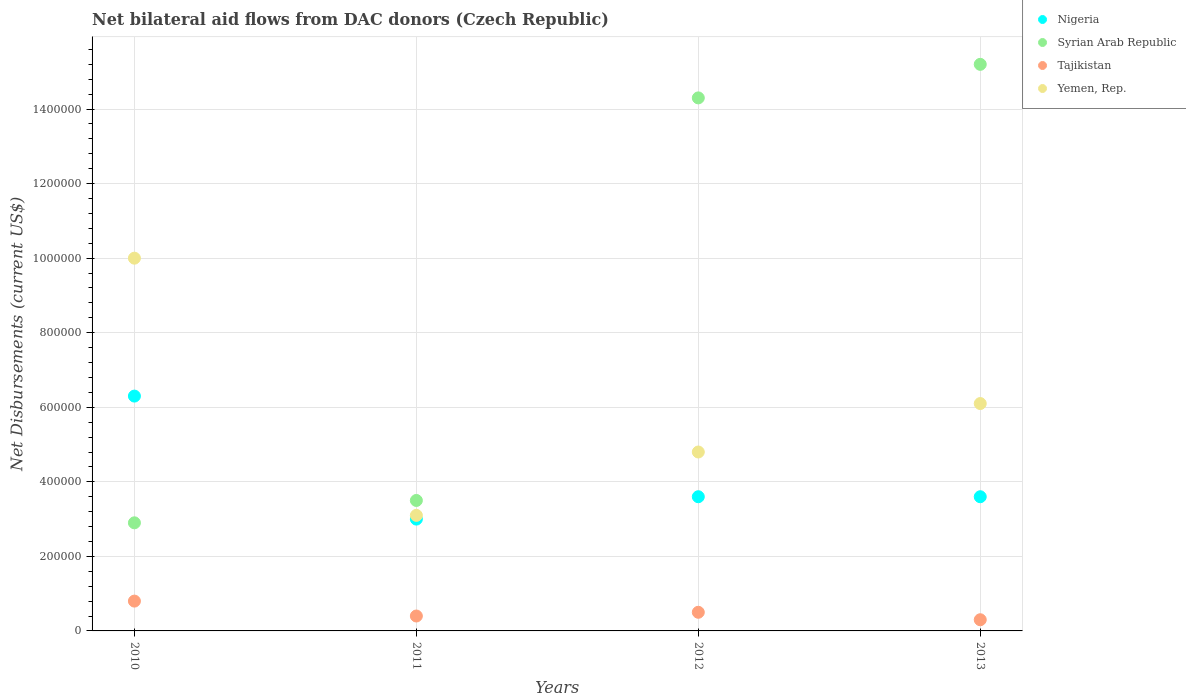How many different coloured dotlines are there?
Provide a short and direct response. 4. What is the net bilateral aid flows in Tajikistan in 2010?
Give a very brief answer. 8.00e+04. Across all years, what is the maximum net bilateral aid flows in Nigeria?
Offer a very short reply. 6.30e+05. Across all years, what is the minimum net bilateral aid flows in Syrian Arab Republic?
Offer a terse response. 2.90e+05. What is the total net bilateral aid flows in Syrian Arab Republic in the graph?
Provide a short and direct response. 3.59e+06. What is the difference between the net bilateral aid flows in Syrian Arab Republic in 2010 and that in 2011?
Make the answer very short. -6.00e+04. What is the difference between the net bilateral aid flows in Nigeria in 2013 and the net bilateral aid flows in Tajikistan in 2012?
Keep it short and to the point. 3.10e+05. What is the average net bilateral aid flows in Tajikistan per year?
Your response must be concise. 5.00e+04. In the year 2013, what is the difference between the net bilateral aid flows in Tajikistan and net bilateral aid flows in Nigeria?
Offer a very short reply. -3.30e+05. In how many years, is the net bilateral aid flows in Yemen, Rep. greater than 440000 US$?
Offer a very short reply. 3. What is the ratio of the net bilateral aid flows in Yemen, Rep. in 2011 to that in 2012?
Ensure brevity in your answer.  0.65. Is the difference between the net bilateral aid flows in Tajikistan in 2011 and 2012 greater than the difference between the net bilateral aid flows in Nigeria in 2011 and 2012?
Offer a very short reply. Yes. What is the difference between the highest and the second highest net bilateral aid flows in Tajikistan?
Your answer should be compact. 3.00e+04. What is the difference between the highest and the lowest net bilateral aid flows in Syrian Arab Republic?
Give a very brief answer. 1.23e+06. Is it the case that in every year, the sum of the net bilateral aid flows in Yemen, Rep. and net bilateral aid flows in Nigeria  is greater than the sum of net bilateral aid flows in Syrian Arab Republic and net bilateral aid flows in Tajikistan?
Offer a very short reply. No. Is the net bilateral aid flows in Syrian Arab Republic strictly greater than the net bilateral aid flows in Nigeria over the years?
Your answer should be compact. No. Is the net bilateral aid flows in Nigeria strictly less than the net bilateral aid flows in Yemen, Rep. over the years?
Your answer should be compact. Yes. How many years are there in the graph?
Provide a short and direct response. 4. Does the graph contain any zero values?
Provide a succinct answer. No. Does the graph contain grids?
Give a very brief answer. Yes. What is the title of the graph?
Provide a succinct answer. Net bilateral aid flows from DAC donors (Czech Republic). Does "Maldives" appear as one of the legend labels in the graph?
Provide a short and direct response. No. What is the label or title of the Y-axis?
Offer a very short reply. Net Disbursements (current US$). What is the Net Disbursements (current US$) in Nigeria in 2010?
Your answer should be compact. 6.30e+05. What is the Net Disbursements (current US$) in Syrian Arab Republic in 2010?
Your response must be concise. 2.90e+05. What is the Net Disbursements (current US$) in Tajikistan in 2010?
Give a very brief answer. 8.00e+04. What is the Net Disbursements (current US$) of Syrian Arab Republic in 2011?
Your answer should be very brief. 3.50e+05. What is the Net Disbursements (current US$) in Tajikistan in 2011?
Give a very brief answer. 4.00e+04. What is the Net Disbursements (current US$) in Nigeria in 2012?
Your answer should be compact. 3.60e+05. What is the Net Disbursements (current US$) in Syrian Arab Republic in 2012?
Provide a short and direct response. 1.43e+06. What is the Net Disbursements (current US$) in Tajikistan in 2012?
Provide a succinct answer. 5.00e+04. What is the Net Disbursements (current US$) of Nigeria in 2013?
Offer a terse response. 3.60e+05. What is the Net Disbursements (current US$) of Syrian Arab Republic in 2013?
Provide a succinct answer. 1.52e+06. Across all years, what is the maximum Net Disbursements (current US$) in Nigeria?
Your answer should be very brief. 6.30e+05. Across all years, what is the maximum Net Disbursements (current US$) of Syrian Arab Republic?
Ensure brevity in your answer.  1.52e+06. Across all years, what is the maximum Net Disbursements (current US$) of Tajikistan?
Provide a succinct answer. 8.00e+04. Across all years, what is the minimum Net Disbursements (current US$) of Syrian Arab Republic?
Your answer should be very brief. 2.90e+05. Across all years, what is the minimum Net Disbursements (current US$) of Tajikistan?
Provide a succinct answer. 3.00e+04. What is the total Net Disbursements (current US$) in Nigeria in the graph?
Your answer should be compact. 1.65e+06. What is the total Net Disbursements (current US$) of Syrian Arab Republic in the graph?
Your response must be concise. 3.59e+06. What is the total Net Disbursements (current US$) of Yemen, Rep. in the graph?
Your answer should be compact. 2.40e+06. What is the difference between the Net Disbursements (current US$) in Syrian Arab Republic in 2010 and that in 2011?
Offer a very short reply. -6.00e+04. What is the difference between the Net Disbursements (current US$) in Tajikistan in 2010 and that in 2011?
Offer a terse response. 4.00e+04. What is the difference between the Net Disbursements (current US$) of Yemen, Rep. in 2010 and that in 2011?
Provide a short and direct response. 6.90e+05. What is the difference between the Net Disbursements (current US$) in Syrian Arab Republic in 2010 and that in 2012?
Offer a very short reply. -1.14e+06. What is the difference between the Net Disbursements (current US$) in Yemen, Rep. in 2010 and that in 2012?
Offer a terse response. 5.20e+05. What is the difference between the Net Disbursements (current US$) of Nigeria in 2010 and that in 2013?
Provide a short and direct response. 2.70e+05. What is the difference between the Net Disbursements (current US$) of Syrian Arab Republic in 2010 and that in 2013?
Your answer should be very brief. -1.23e+06. What is the difference between the Net Disbursements (current US$) in Nigeria in 2011 and that in 2012?
Give a very brief answer. -6.00e+04. What is the difference between the Net Disbursements (current US$) in Syrian Arab Republic in 2011 and that in 2012?
Give a very brief answer. -1.08e+06. What is the difference between the Net Disbursements (current US$) in Syrian Arab Republic in 2011 and that in 2013?
Keep it short and to the point. -1.17e+06. What is the difference between the Net Disbursements (current US$) of Tajikistan in 2011 and that in 2013?
Offer a terse response. 10000. What is the difference between the Net Disbursements (current US$) of Nigeria in 2012 and that in 2013?
Provide a short and direct response. 0. What is the difference between the Net Disbursements (current US$) in Syrian Arab Republic in 2012 and that in 2013?
Provide a short and direct response. -9.00e+04. What is the difference between the Net Disbursements (current US$) of Tajikistan in 2012 and that in 2013?
Your response must be concise. 2.00e+04. What is the difference between the Net Disbursements (current US$) of Yemen, Rep. in 2012 and that in 2013?
Keep it short and to the point. -1.30e+05. What is the difference between the Net Disbursements (current US$) of Nigeria in 2010 and the Net Disbursements (current US$) of Syrian Arab Republic in 2011?
Your answer should be compact. 2.80e+05. What is the difference between the Net Disbursements (current US$) in Nigeria in 2010 and the Net Disbursements (current US$) in Tajikistan in 2011?
Provide a succinct answer. 5.90e+05. What is the difference between the Net Disbursements (current US$) of Syrian Arab Republic in 2010 and the Net Disbursements (current US$) of Tajikistan in 2011?
Your answer should be compact. 2.50e+05. What is the difference between the Net Disbursements (current US$) in Syrian Arab Republic in 2010 and the Net Disbursements (current US$) in Yemen, Rep. in 2011?
Make the answer very short. -2.00e+04. What is the difference between the Net Disbursements (current US$) of Nigeria in 2010 and the Net Disbursements (current US$) of Syrian Arab Republic in 2012?
Ensure brevity in your answer.  -8.00e+05. What is the difference between the Net Disbursements (current US$) of Nigeria in 2010 and the Net Disbursements (current US$) of Tajikistan in 2012?
Give a very brief answer. 5.80e+05. What is the difference between the Net Disbursements (current US$) of Nigeria in 2010 and the Net Disbursements (current US$) of Yemen, Rep. in 2012?
Your answer should be compact. 1.50e+05. What is the difference between the Net Disbursements (current US$) in Tajikistan in 2010 and the Net Disbursements (current US$) in Yemen, Rep. in 2012?
Provide a succinct answer. -4.00e+05. What is the difference between the Net Disbursements (current US$) in Nigeria in 2010 and the Net Disbursements (current US$) in Syrian Arab Republic in 2013?
Offer a very short reply. -8.90e+05. What is the difference between the Net Disbursements (current US$) of Syrian Arab Republic in 2010 and the Net Disbursements (current US$) of Yemen, Rep. in 2013?
Your answer should be compact. -3.20e+05. What is the difference between the Net Disbursements (current US$) of Tajikistan in 2010 and the Net Disbursements (current US$) of Yemen, Rep. in 2013?
Your response must be concise. -5.30e+05. What is the difference between the Net Disbursements (current US$) in Nigeria in 2011 and the Net Disbursements (current US$) in Syrian Arab Republic in 2012?
Give a very brief answer. -1.13e+06. What is the difference between the Net Disbursements (current US$) of Nigeria in 2011 and the Net Disbursements (current US$) of Yemen, Rep. in 2012?
Offer a very short reply. -1.80e+05. What is the difference between the Net Disbursements (current US$) of Syrian Arab Republic in 2011 and the Net Disbursements (current US$) of Tajikistan in 2012?
Your response must be concise. 3.00e+05. What is the difference between the Net Disbursements (current US$) of Syrian Arab Republic in 2011 and the Net Disbursements (current US$) of Yemen, Rep. in 2012?
Your answer should be very brief. -1.30e+05. What is the difference between the Net Disbursements (current US$) in Tajikistan in 2011 and the Net Disbursements (current US$) in Yemen, Rep. in 2012?
Your response must be concise. -4.40e+05. What is the difference between the Net Disbursements (current US$) in Nigeria in 2011 and the Net Disbursements (current US$) in Syrian Arab Republic in 2013?
Keep it short and to the point. -1.22e+06. What is the difference between the Net Disbursements (current US$) of Nigeria in 2011 and the Net Disbursements (current US$) of Tajikistan in 2013?
Provide a short and direct response. 2.70e+05. What is the difference between the Net Disbursements (current US$) in Nigeria in 2011 and the Net Disbursements (current US$) in Yemen, Rep. in 2013?
Your answer should be very brief. -3.10e+05. What is the difference between the Net Disbursements (current US$) in Syrian Arab Republic in 2011 and the Net Disbursements (current US$) in Yemen, Rep. in 2013?
Provide a short and direct response. -2.60e+05. What is the difference between the Net Disbursements (current US$) in Tajikistan in 2011 and the Net Disbursements (current US$) in Yemen, Rep. in 2013?
Your response must be concise. -5.70e+05. What is the difference between the Net Disbursements (current US$) in Nigeria in 2012 and the Net Disbursements (current US$) in Syrian Arab Republic in 2013?
Give a very brief answer. -1.16e+06. What is the difference between the Net Disbursements (current US$) of Syrian Arab Republic in 2012 and the Net Disbursements (current US$) of Tajikistan in 2013?
Provide a short and direct response. 1.40e+06. What is the difference between the Net Disbursements (current US$) in Syrian Arab Republic in 2012 and the Net Disbursements (current US$) in Yemen, Rep. in 2013?
Your response must be concise. 8.20e+05. What is the difference between the Net Disbursements (current US$) in Tajikistan in 2012 and the Net Disbursements (current US$) in Yemen, Rep. in 2013?
Your response must be concise. -5.60e+05. What is the average Net Disbursements (current US$) in Nigeria per year?
Your answer should be very brief. 4.12e+05. What is the average Net Disbursements (current US$) in Syrian Arab Republic per year?
Your answer should be compact. 8.98e+05. What is the average Net Disbursements (current US$) of Yemen, Rep. per year?
Your answer should be compact. 6.00e+05. In the year 2010, what is the difference between the Net Disbursements (current US$) in Nigeria and Net Disbursements (current US$) in Yemen, Rep.?
Offer a very short reply. -3.70e+05. In the year 2010, what is the difference between the Net Disbursements (current US$) in Syrian Arab Republic and Net Disbursements (current US$) in Tajikistan?
Offer a very short reply. 2.10e+05. In the year 2010, what is the difference between the Net Disbursements (current US$) of Syrian Arab Republic and Net Disbursements (current US$) of Yemen, Rep.?
Make the answer very short. -7.10e+05. In the year 2010, what is the difference between the Net Disbursements (current US$) in Tajikistan and Net Disbursements (current US$) in Yemen, Rep.?
Give a very brief answer. -9.20e+05. In the year 2011, what is the difference between the Net Disbursements (current US$) of Syrian Arab Republic and Net Disbursements (current US$) of Tajikistan?
Make the answer very short. 3.10e+05. In the year 2011, what is the difference between the Net Disbursements (current US$) of Syrian Arab Republic and Net Disbursements (current US$) of Yemen, Rep.?
Offer a very short reply. 4.00e+04. In the year 2011, what is the difference between the Net Disbursements (current US$) of Tajikistan and Net Disbursements (current US$) of Yemen, Rep.?
Make the answer very short. -2.70e+05. In the year 2012, what is the difference between the Net Disbursements (current US$) in Nigeria and Net Disbursements (current US$) in Syrian Arab Republic?
Your response must be concise. -1.07e+06. In the year 2012, what is the difference between the Net Disbursements (current US$) of Syrian Arab Republic and Net Disbursements (current US$) of Tajikistan?
Your answer should be compact. 1.38e+06. In the year 2012, what is the difference between the Net Disbursements (current US$) in Syrian Arab Republic and Net Disbursements (current US$) in Yemen, Rep.?
Offer a very short reply. 9.50e+05. In the year 2012, what is the difference between the Net Disbursements (current US$) in Tajikistan and Net Disbursements (current US$) in Yemen, Rep.?
Your response must be concise. -4.30e+05. In the year 2013, what is the difference between the Net Disbursements (current US$) of Nigeria and Net Disbursements (current US$) of Syrian Arab Republic?
Ensure brevity in your answer.  -1.16e+06. In the year 2013, what is the difference between the Net Disbursements (current US$) of Nigeria and Net Disbursements (current US$) of Yemen, Rep.?
Your response must be concise. -2.50e+05. In the year 2013, what is the difference between the Net Disbursements (current US$) in Syrian Arab Republic and Net Disbursements (current US$) in Tajikistan?
Keep it short and to the point. 1.49e+06. In the year 2013, what is the difference between the Net Disbursements (current US$) in Syrian Arab Republic and Net Disbursements (current US$) in Yemen, Rep.?
Keep it short and to the point. 9.10e+05. In the year 2013, what is the difference between the Net Disbursements (current US$) in Tajikistan and Net Disbursements (current US$) in Yemen, Rep.?
Give a very brief answer. -5.80e+05. What is the ratio of the Net Disbursements (current US$) of Nigeria in 2010 to that in 2011?
Keep it short and to the point. 2.1. What is the ratio of the Net Disbursements (current US$) in Syrian Arab Republic in 2010 to that in 2011?
Your response must be concise. 0.83. What is the ratio of the Net Disbursements (current US$) in Tajikistan in 2010 to that in 2011?
Ensure brevity in your answer.  2. What is the ratio of the Net Disbursements (current US$) in Yemen, Rep. in 2010 to that in 2011?
Give a very brief answer. 3.23. What is the ratio of the Net Disbursements (current US$) in Nigeria in 2010 to that in 2012?
Your answer should be compact. 1.75. What is the ratio of the Net Disbursements (current US$) of Syrian Arab Republic in 2010 to that in 2012?
Ensure brevity in your answer.  0.2. What is the ratio of the Net Disbursements (current US$) in Yemen, Rep. in 2010 to that in 2012?
Give a very brief answer. 2.08. What is the ratio of the Net Disbursements (current US$) of Nigeria in 2010 to that in 2013?
Your answer should be compact. 1.75. What is the ratio of the Net Disbursements (current US$) in Syrian Arab Republic in 2010 to that in 2013?
Offer a terse response. 0.19. What is the ratio of the Net Disbursements (current US$) of Tajikistan in 2010 to that in 2013?
Offer a very short reply. 2.67. What is the ratio of the Net Disbursements (current US$) of Yemen, Rep. in 2010 to that in 2013?
Your response must be concise. 1.64. What is the ratio of the Net Disbursements (current US$) in Nigeria in 2011 to that in 2012?
Your answer should be very brief. 0.83. What is the ratio of the Net Disbursements (current US$) in Syrian Arab Republic in 2011 to that in 2012?
Give a very brief answer. 0.24. What is the ratio of the Net Disbursements (current US$) in Yemen, Rep. in 2011 to that in 2012?
Ensure brevity in your answer.  0.65. What is the ratio of the Net Disbursements (current US$) of Nigeria in 2011 to that in 2013?
Give a very brief answer. 0.83. What is the ratio of the Net Disbursements (current US$) of Syrian Arab Republic in 2011 to that in 2013?
Keep it short and to the point. 0.23. What is the ratio of the Net Disbursements (current US$) in Yemen, Rep. in 2011 to that in 2013?
Your response must be concise. 0.51. What is the ratio of the Net Disbursements (current US$) in Syrian Arab Republic in 2012 to that in 2013?
Your answer should be compact. 0.94. What is the ratio of the Net Disbursements (current US$) of Yemen, Rep. in 2012 to that in 2013?
Ensure brevity in your answer.  0.79. What is the difference between the highest and the second highest Net Disbursements (current US$) in Yemen, Rep.?
Your answer should be compact. 3.90e+05. What is the difference between the highest and the lowest Net Disbursements (current US$) in Syrian Arab Republic?
Provide a short and direct response. 1.23e+06. What is the difference between the highest and the lowest Net Disbursements (current US$) of Tajikistan?
Offer a terse response. 5.00e+04. What is the difference between the highest and the lowest Net Disbursements (current US$) in Yemen, Rep.?
Offer a terse response. 6.90e+05. 